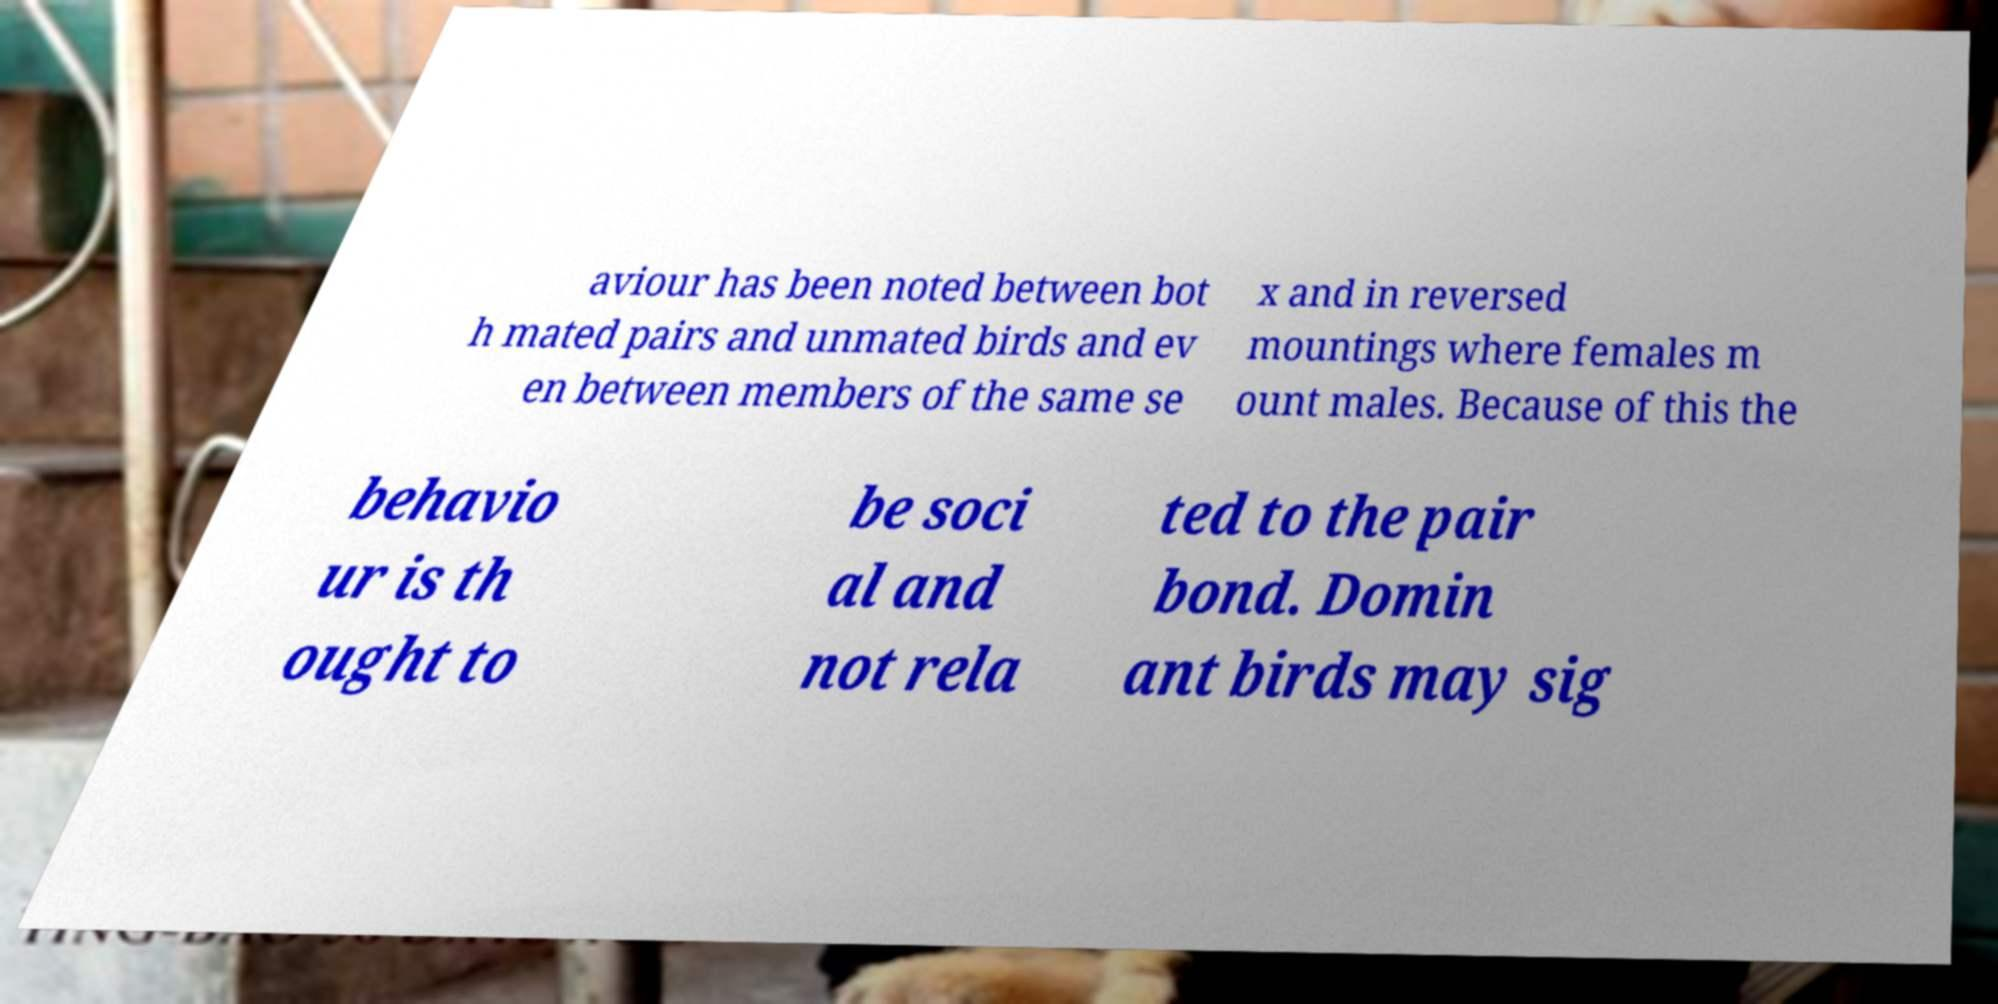Please identify and transcribe the text found in this image. The visible text transcribed from the image is: 'aviour has been noted between both mated pairs and unmated birds and even between members of the same sex and in reversed mountings where females mount males. Because of this the behaviour is thought to be social and not related to the pair bond. Dominant birds may sig'. This excerpt discusses observed behaviors in birds, possibly indicating that certain actions are more socially motivated rather than linked to mating. 